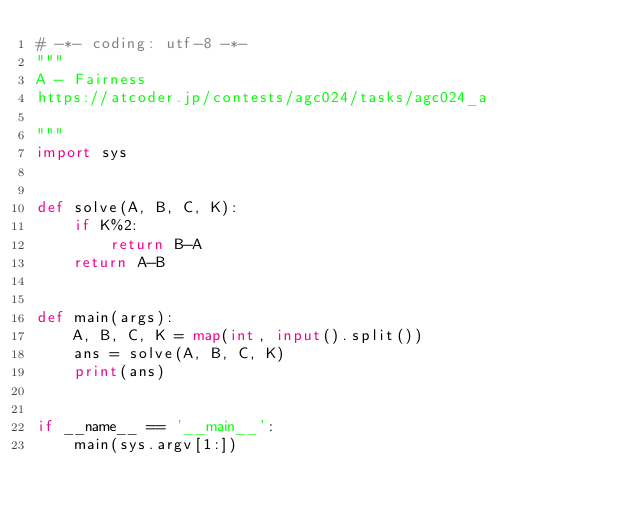Convert code to text. <code><loc_0><loc_0><loc_500><loc_500><_Python_># -*- coding: utf-8 -*-
"""
A - Fairness
https://atcoder.jp/contests/agc024/tasks/agc024_a

"""
import sys


def solve(A, B, C, K):
    if K%2:
        return B-A
    return A-B


def main(args):
    A, B, C, K = map(int, input().split())
    ans = solve(A, B, C, K)
    print(ans)


if __name__ == '__main__':
    main(sys.argv[1:])
</code> 